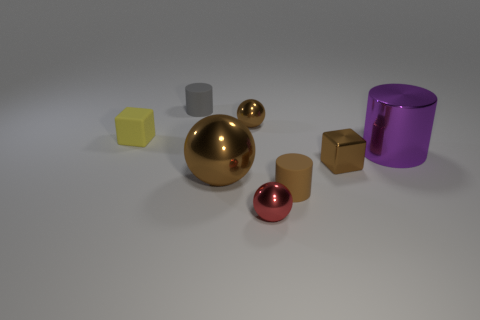Subtract all small metallic spheres. How many spheres are left? 1 Add 1 small yellow rubber cylinders. How many objects exist? 9 Subtract all brown cylinders. How many brown balls are left? 2 Subtract all red balls. How many balls are left? 2 Subtract 1 spheres. How many spheres are left? 2 Subtract all cylinders. How many objects are left? 5 Subtract all gray objects. Subtract all small rubber cylinders. How many objects are left? 5 Add 5 purple objects. How many purple objects are left? 6 Add 8 small shiny cylinders. How many small shiny cylinders exist? 8 Subtract 0 green cubes. How many objects are left? 8 